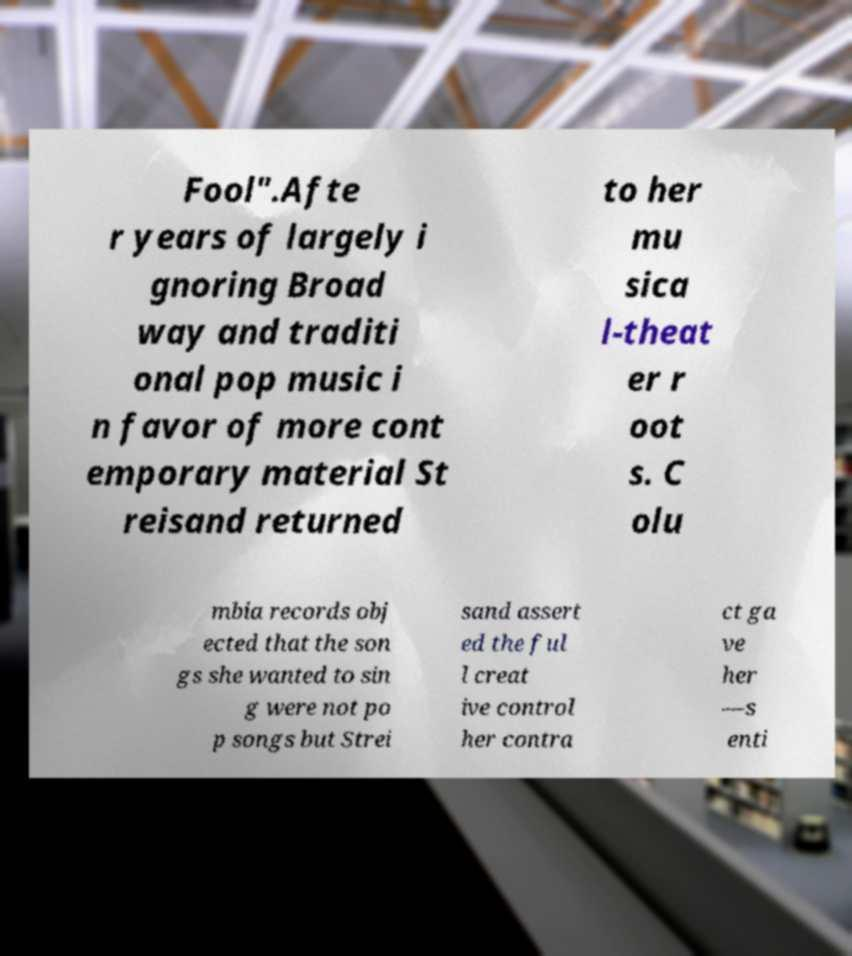Can you accurately transcribe the text from the provided image for me? Fool".Afte r years of largely i gnoring Broad way and traditi onal pop music i n favor of more cont emporary material St reisand returned to her mu sica l-theat er r oot s. C olu mbia records obj ected that the son gs she wanted to sin g were not po p songs but Strei sand assert ed the ful l creat ive control her contra ct ga ve her —s enti 